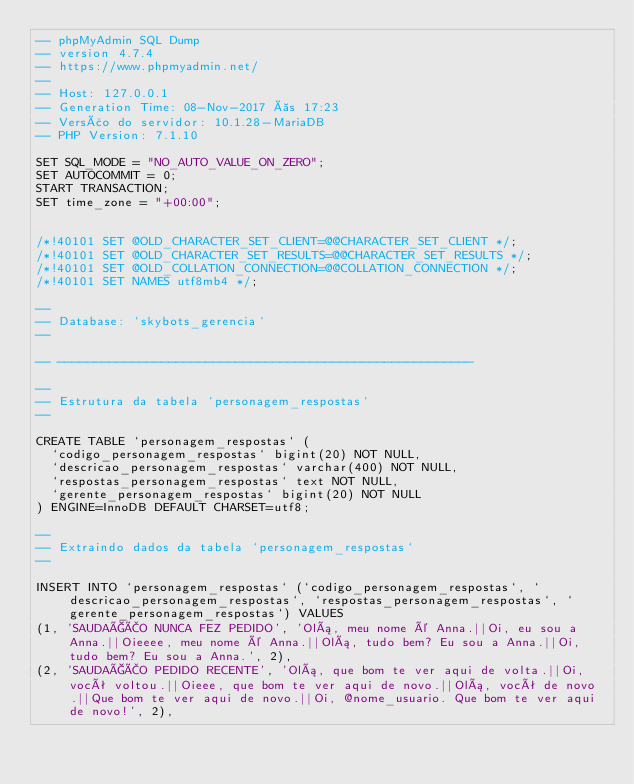<code> <loc_0><loc_0><loc_500><loc_500><_SQL_>-- phpMyAdmin SQL Dump
-- version 4.7.4
-- https://www.phpmyadmin.net/
--
-- Host: 127.0.0.1
-- Generation Time: 08-Nov-2017 às 17:23
-- Versão do servidor: 10.1.28-MariaDB
-- PHP Version: 7.1.10

SET SQL_MODE = "NO_AUTO_VALUE_ON_ZERO";
SET AUTOCOMMIT = 0;
START TRANSACTION;
SET time_zone = "+00:00";


/*!40101 SET @OLD_CHARACTER_SET_CLIENT=@@CHARACTER_SET_CLIENT */;
/*!40101 SET @OLD_CHARACTER_SET_RESULTS=@@CHARACTER_SET_RESULTS */;
/*!40101 SET @OLD_COLLATION_CONNECTION=@@COLLATION_CONNECTION */;
/*!40101 SET NAMES utf8mb4 */;

--
-- Database: `skybots_gerencia`
--

-- --------------------------------------------------------

--
-- Estrutura da tabela `personagem_respostas`
--

CREATE TABLE `personagem_respostas` (
  `codigo_personagem_respostas` bigint(20) NOT NULL,
  `descricao_personagem_respostas` varchar(400) NOT NULL,
  `respostas_personagem_respostas` text NOT NULL,
  `gerente_personagem_respostas` bigint(20) NOT NULL
) ENGINE=InnoDB DEFAULT CHARSET=utf8;

--
-- Extraindo dados da tabela `personagem_respostas`
--

INSERT INTO `personagem_respostas` (`codigo_personagem_respostas`, `descricao_personagem_respostas`, `respostas_personagem_respostas`, `gerente_personagem_respostas`) VALUES
(1, 'SAUDAÇÃO NUNCA FEZ PEDIDO', 'Olá, meu nome é Anna.||Oi, eu sou a Anna.||Oieeee, meu nome é Anna.||Olá, tudo bem? Eu sou a Anna.||Oi, tudo bem? Eu sou a Anna.', 2),
(2, 'SAUDAÇÃO PEDIDO RECENTE', 'Olá, que bom te ver aqui de volta.||Oi, você voltou.||Oieee, que bom te ver aqui de novo.||Olá, você de novo.||Que bom te ver aqui de novo.||Oi, @nome_usuario. Que bom te ver aqui de novo!', 2),</code> 